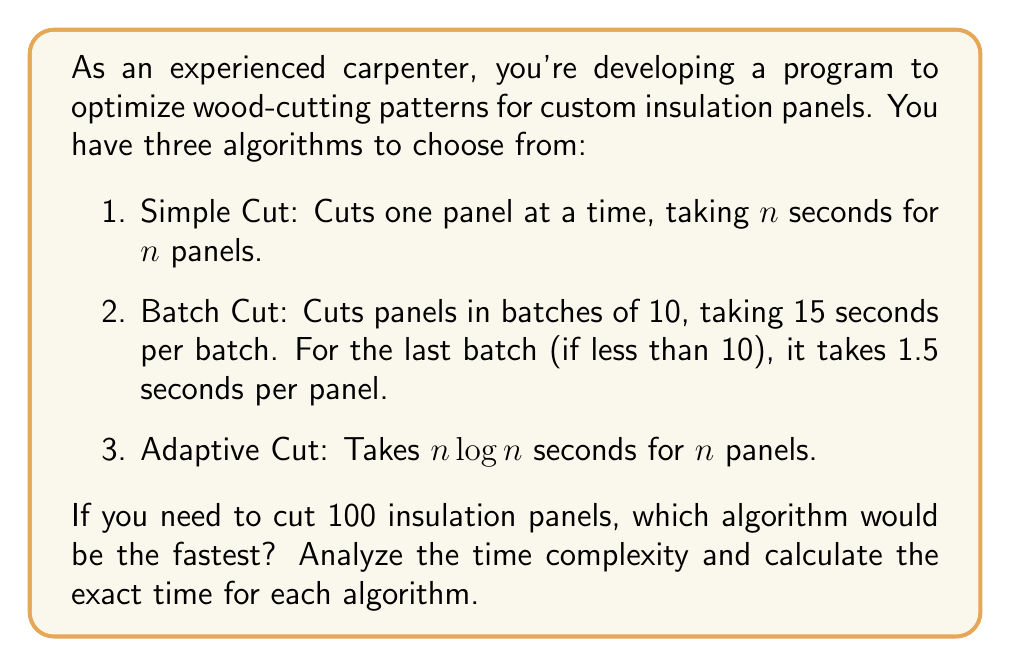Help me with this question. Let's analyze each algorithm for $n = 100$ panels:

1. Simple Cut:
   Time complexity: $O(n)$
   Exact time: $T(n) = n$ seconds
   For 100 panels: $T(100) = 100$ seconds

2. Batch Cut:
   Time complexity: $O(n)$
   Exact time calculation:
   - Number of full batches: $\lfloor \frac{n}{10} \rfloor = \lfloor \frac{100}{10} \rfloor = 10$
   - Time for full batches: $10 \times 15 = 150$ seconds
   - No remaining panels in the last batch
   Total time: 150 seconds

3. Adaptive Cut:
   Time complexity: $O(n \log n)$
   Exact time: $T(n) = n \log n$ seconds
   For 100 panels: $T(100) = 100 \log 100 \approx 200$ seconds

Comparing the results:
- Simple Cut: 100 seconds
- Batch Cut: 150 seconds
- Adaptive Cut: ~200 seconds

The Simple Cut algorithm is the fastest for 100 panels.
Answer: The Simple Cut algorithm is the fastest, taking 100 seconds to cut 100 insulation panels. 